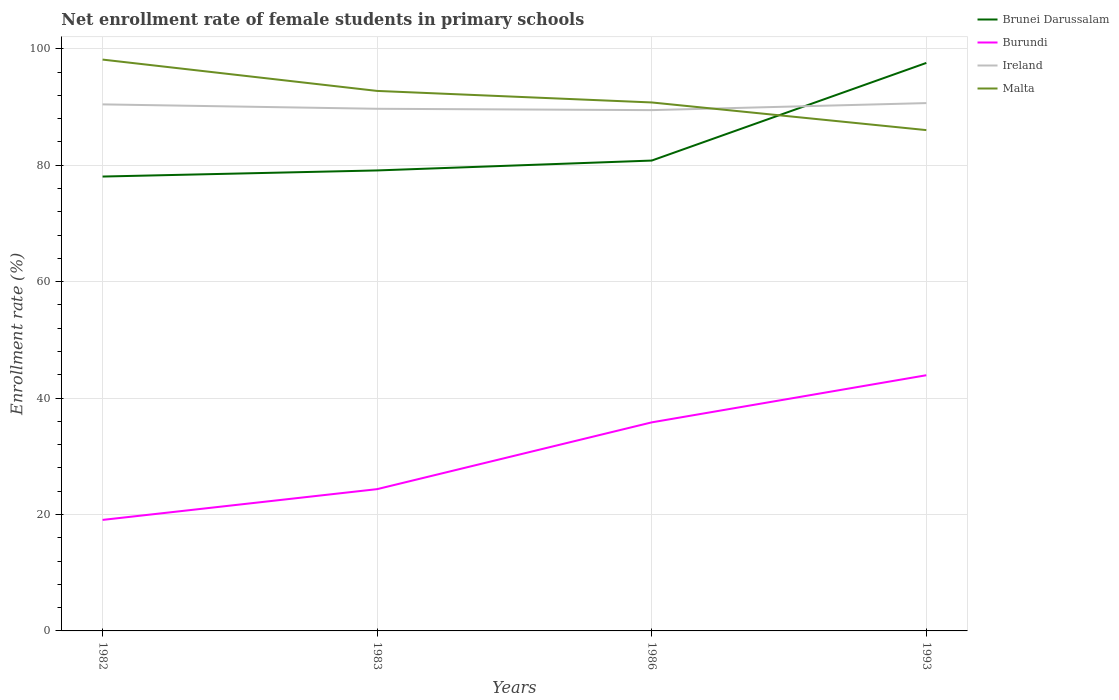How many different coloured lines are there?
Your response must be concise. 4. Does the line corresponding to Burundi intersect with the line corresponding to Brunei Darussalam?
Give a very brief answer. No. Across all years, what is the maximum net enrollment rate of female students in primary schools in Malta?
Ensure brevity in your answer.  86.04. In which year was the net enrollment rate of female students in primary schools in Malta maximum?
Give a very brief answer. 1993. What is the total net enrollment rate of female students in primary schools in Brunei Darussalam in the graph?
Give a very brief answer. -2.75. What is the difference between the highest and the second highest net enrollment rate of female students in primary schools in Burundi?
Your answer should be compact. 24.85. How many years are there in the graph?
Ensure brevity in your answer.  4. Does the graph contain any zero values?
Your response must be concise. No. How many legend labels are there?
Offer a terse response. 4. How are the legend labels stacked?
Offer a very short reply. Vertical. What is the title of the graph?
Your answer should be very brief. Net enrollment rate of female students in primary schools. Does "Russian Federation" appear as one of the legend labels in the graph?
Keep it short and to the point. No. What is the label or title of the Y-axis?
Your answer should be compact. Enrollment rate (%). What is the Enrollment rate (%) of Brunei Darussalam in 1982?
Give a very brief answer. 78.06. What is the Enrollment rate (%) in Burundi in 1982?
Your answer should be compact. 19.07. What is the Enrollment rate (%) in Ireland in 1982?
Provide a succinct answer. 90.46. What is the Enrollment rate (%) in Malta in 1982?
Your response must be concise. 98.16. What is the Enrollment rate (%) of Brunei Darussalam in 1983?
Offer a terse response. 79.11. What is the Enrollment rate (%) of Burundi in 1983?
Offer a very short reply. 24.36. What is the Enrollment rate (%) of Ireland in 1983?
Give a very brief answer. 89.7. What is the Enrollment rate (%) of Malta in 1983?
Offer a terse response. 92.77. What is the Enrollment rate (%) in Brunei Darussalam in 1986?
Ensure brevity in your answer.  80.81. What is the Enrollment rate (%) of Burundi in 1986?
Ensure brevity in your answer.  35.83. What is the Enrollment rate (%) of Ireland in 1986?
Keep it short and to the point. 89.47. What is the Enrollment rate (%) of Malta in 1986?
Offer a very short reply. 90.79. What is the Enrollment rate (%) in Brunei Darussalam in 1993?
Offer a very short reply. 97.58. What is the Enrollment rate (%) in Burundi in 1993?
Your response must be concise. 43.93. What is the Enrollment rate (%) of Ireland in 1993?
Offer a terse response. 90.68. What is the Enrollment rate (%) of Malta in 1993?
Provide a succinct answer. 86.04. Across all years, what is the maximum Enrollment rate (%) of Brunei Darussalam?
Keep it short and to the point. 97.58. Across all years, what is the maximum Enrollment rate (%) of Burundi?
Your answer should be compact. 43.93. Across all years, what is the maximum Enrollment rate (%) of Ireland?
Provide a short and direct response. 90.68. Across all years, what is the maximum Enrollment rate (%) in Malta?
Provide a succinct answer. 98.16. Across all years, what is the minimum Enrollment rate (%) of Brunei Darussalam?
Ensure brevity in your answer.  78.06. Across all years, what is the minimum Enrollment rate (%) of Burundi?
Keep it short and to the point. 19.07. Across all years, what is the minimum Enrollment rate (%) in Ireland?
Provide a short and direct response. 89.47. Across all years, what is the minimum Enrollment rate (%) of Malta?
Keep it short and to the point. 86.04. What is the total Enrollment rate (%) of Brunei Darussalam in the graph?
Ensure brevity in your answer.  335.56. What is the total Enrollment rate (%) in Burundi in the graph?
Offer a very short reply. 123.19. What is the total Enrollment rate (%) of Ireland in the graph?
Ensure brevity in your answer.  360.32. What is the total Enrollment rate (%) in Malta in the graph?
Keep it short and to the point. 367.76. What is the difference between the Enrollment rate (%) of Brunei Darussalam in 1982 and that in 1983?
Keep it short and to the point. -1.05. What is the difference between the Enrollment rate (%) in Burundi in 1982 and that in 1983?
Ensure brevity in your answer.  -5.29. What is the difference between the Enrollment rate (%) in Ireland in 1982 and that in 1983?
Your answer should be very brief. 0.76. What is the difference between the Enrollment rate (%) of Malta in 1982 and that in 1983?
Provide a short and direct response. 5.38. What is the difference between the Enrollment rate (%) in Brunei Darussalam in 1982 and that in 1986?
Your answer should be compact. -2.75. What is the difference between the Enrollment rate (%) of Burundi in 1982 and that in 1986?
Provide a short and direct response. -16.76. What is the difference between the Enrollment rate (%) of Ireland in 1982 and that in 1986?
Provide a short and direct response. 0.99. What is the difference between the Enrollment rate (%) of Malta in 1982 and that in 1986?
Ensure brevity in your answer.  7.36. What is the difference between the Enrollment rate (%) in Brunei Darussalam in 1982 and that in 1993?
Keep it short and to the point. -19.52. What is the difference between the Enrollment rate (%) in Burundi in 1982 and that in 1993?
Ensure brevity in your answer.  -24.85. What is the difference between the Enrollment rate (%) in Ireland in 1982 and that in 1993?
Offer a terse response. -0.22. What is the difference between the Enrollment rate (%) of Malta in 1982 and that in 1993?
Give a very brief answer. 12.11. What is the difference between the Enrollment rate (%) in Brunei Darussalam in 1983 and that in 1986?
Your answer should be very brief. -1.7. What is the difference between the Enrollment rate (%) of Burundi in 1983 and that in 1986?
Your answer should be very brief. -11.47. What is the difference between the Enrollment rate (%) of Ireland in 1983 and that in 1986?
Provide a succinct answer. 0.23. What is the difference between the Enrollment rate (%) in Malta in 1983 and that in 1986?
Your answer should be very brief. 1.98. What is the difference between the Enrollment rate (%) in Brunei Darussalam in 1983 and that in 1993?
Give a very brief answer. -18.47. What is the difference between the Enrollment rate (%) in Burundi in 1983 and that in 1993?
Provide a short and direct response. -19.57. What is the difference between the Enrollment rate (%) of Ireland in 1983 and that in 1993?
Give a very brief answer. -0.98. What is the difference between the Enrollment rate (%) of Malta in 1983 and that in 1993?
Offer a terse response. 6.73. What is the difference between the Enrollment rate (%) of Brunei Darussalam in 1986 and that in 1993?
Your answer should be very brief. -16.77. What is the difference between the Enrollment rate (%) of Burundi in 1986 and that in 1993?
Provide a succinct answer. -8.1. What is the difference between the Enrollment rate (%) in Ireland in 1986 and that in 1993?
Offer a terse response. -1.21. What is the difference between the Enrollment rate (%) in Malta in 1986 and that in 1993?
Keep it short and to the point. 4.75. What is the difference between the Enrollment rate (%) in Brunei Darussalam in 1982 and the Enrollment rate (%) in Burundi in 1983?
Ensure brevity in your answer.  53.7. What is the difference between the Enrollment rate (%) in Brunei Darussalam in 1982 and the Enrollment rate (%) in Ireland in 1983?
Your answer should be very brief. -11.64. What is the difference between the Enrollment rate (%) of Brunei Darussalam in 1982 and the Enrollment rate (%) of Malta in 1983?
Your answer should be compact. -14.71. What is the difference between the Enrollment rate (%) of Burundi in 1982 and the Enrollment rate (%) of Ireland in 1983?
Your answer should be compact. -70.63. What is the difference between the Enrollment rate (%) in Burundi in 1982 and the Enrollment rate (%) in Malta in 1983?
Ensure brevity in your answer.  -73.7. What is the difference between the Enrollment rate (%) in Ireland in 1982 and the Enrollment rate (%) in Malta in 1983?
Offer a terse response. -2.31. What is the difference between the Enrollment rate (%) in Brunei Darussalam in 1982 and the Enrollment rate (%) in Burundi in 1986?
Your answer should be compact. 42.23. What is the difference between the Enrollment rate (%) of Brunei Darussalam in 1982 and the Enrollment rate (%) of Ireland in 1986?
Give a very brief answer. -11.41. What is the difference between the Enrollment rate (%) of Brunei Darussalam in 1982 and the Enrollment rate (%) of Malta in 1986?
Your response must be concise. -12.73. What is the difference between the Enrollment rate (%) of Burundi in 1982 and the Enrollment rate (%) of Ireland in 1986?
Keep it short and to the point. -70.4. What is the difference between the Enrollment rate (%) of Burundi in 1982 and the Enrollment rate (%) of Malta in 1986?
Provide a succinct answer. -71.72. What is the difference between the Enrollment rate (%) in Ireland in 1982 and the Enrollment rate (%) in Malta in 1986?
Your response must be concise. -0.33. What is the difference between the Enrollment rate (%) of Brunei Darussalam in 1982 and the Enrollment rate (%) of Burundi in 1993?
Provide a short and direct response. 34.13. What is the difference between the Enrollment rate (%) of Brunei Darussalam in 1982 and the Enrollment rate (%) of Ireland in 1993?
Make the answer very short. -12.62. What is the difference between the Enrollment rate (%) in Brunei Darussalam in 1982 and the Enrollment rate (%) in Malta in 1993?
Your answer should be compact. -7.98. What is the difference between the Enrollment rate (%) of Burundi in 1982 and the Enrollment rate (%) of Ireland in 1993?
Provide a short and direct response. -71.61. What is the difference between the Enrollment rate (%) in Burundi in 1982 and the Enrollment rate (%) in Malta in 1993?
Offer a terse response. -66.97. What is the difference between the Enrollment rate (%) in Ireland in 1982 and the Enrollment rate (%) in Malta in 1993?
Ensure brevity in your answer.  4.42. What is the difference between the Enrollment rate (%) in Brunei Darussalam in 1983 and the Enrollment rate (%) in Burundi in 1986?
Your answer should be compact. 43.28. What is the difference between the Enrollment rate (%) of Brunei Darussalam in 1983 and the Enrollment rate (%) of Ireland in 1986?
Offer a terse response. -10.36. What is the difference between the Enrollment rate (%) of Brunei Darussalam in 1983 and the Enrollment rate (%) of Malta in 1986?
Offer a terse response. -11.68. What is the difference between the Enrollment rate (%) of Burundi in 1983 and the Enrollment rate (%) of Ireland in 1986?
Offer a very short reply. -65.11. What is the difference between the Enrollment rate (%) in Burundi in 1983 and the Enrollment rate (%) in Malta in 1986?
Offer a very short reply. -66.43. What is the difference between the Enrollment rate (%) of Ireland in 1983 and the Enrollment rate (%) of Malta in 1986?
Your answer should be compact. -1.09. What is the difference between the Enrollment rate (%) in Brunei Darussalam in 1983 and the Enrollment rate (%) in Burundi in 1993?
Offer a very short reply. 35.19. What is the difference between the Enrollment rate (%) of Brunei Darussalam in 1983 and the Enrollment rate (%) of Ireland in 1993?
Offer a very short reply. -11.57. What is the difference between the Enrollment rate (%) of Brunei Darussalam in 1983 and the Enrollment rate (%) of Malta in 1993?
Make the answer very short. -6.93. What is the difference between the Enrollment rate (%) of Burundi in 1983 and the Enrollment rate (%) of Ireland in 1993?
Offer a very short reply. -66.32. What is the difference between the Enrollment rate (%) of Burundi in 1983 and the Enrollment rate (%) of Malta in 1993?
Provide a succinct answer. -61.68. What is the difference between the Enrollment rate (%) of Ireland in 1983 and the Enrollment rate (%) of Malta in 1993?
Offer a terse response. 3.66. What is the difference between the Enrollment rate (%) of Brunei Darussalam in 1986 and the Enrollment rate (%) of Burundi in 1993?
Your answer should be very brief. 36.88. What is the difference between the Enrollment rate (%) in Brunei Darussalam in 1986 and the Enrollment rate (%) in Ireland in 1993?
Make the answer very short. -9.87. What is the difference between the Enrollment rate (%) of Brunei Darussalam in 1986 and the Enrollment rate (%) of Malta in 1993?
Ensure brevity in your answer.  -5.23. What is the difference between the Enrollment rate (%) of Burundi in 1986 and the Enrollment rate (%) of Ireland in 1993?
Your answer should be compact. -54.85. What is the difference between the Enrollment rate (%) in Burundi in 1986 and the Enrollment rate (%) in Malta in 1993?
Offer a very short reply. -50.21. What is the difference between the Enrollment rate (%) in Ireland in 1986 and the Enrollment rate (%) in Malta in 1993?
Offer a very short reply. 3.43. What is the average Enrollment rate (%) of Brunei Darussalam per year?
Provide a succinct answer. 83.89. What is the average Enrollment rate (%) in Burundi per year?
Offer a terse response. 30.8. What is the average Enrollment rate (%) of Ireland per year?
Offer a very short reply. 90.08. What is the average Enrollment rate (%) of Malta per year?
Make the answer very short. 91.94. In the year 1982, what is the difference between the Enrollment rate (%) in Brunei Darussalam and Enrollment rate (%) in Burundi?
Ensure brevity in your answer.  58.99. In the year 1982, what is the difference between the Enrollment rate (%) of Brunei Darussalam and Enrollment rate (%) of Ireland?
Give a very brief answer. -12.4. In the year 1982, what is the difference between the Enrollment rate (%) of Brunei Darussalam and Enrollment rate (%) of Malta?
Offer a very short reply. -20.09. In the year 1982, what is the difference between the Enrollment rate (%) of Burundi and Enrollment rate (%) of Ireland?
Offer a terse response. -71.39. In the year 1982, what is the difference between the Enrollment rate (%) of Burundi and Enrollment rate (%) of Malta?
Your answer should be compact. -79.08. In the year 1982, what is the difference between the Enrollment rate (%) in Ireland and Enrollment rate (%) in Malta?
Give a very brief answer. -7.69. In the year 1983, what is the difference between the Enrollment rate (%) in Brunei Darussalam and Enrollment rate (%) in Burundi?
Keep it short and to the point. 54.75. In the year 1983, what is the difference between the Enrollment rate (%) of Brunei Darussalam and Enrollment rate (%) of Ireland?
Make the answer very short. -10.59. In the year 1983, what is the difference between the Enrollment rate (%) of Brunei Darussalam and Enrollment rate (%) of Malta?
Your answer should be very brief. -13.66. In the year 1983, what is the difference between the Enrollment rate (%) in Burundi and Enrollment rate (%) in Ireland?
Your response must be concise. -65.34. In the year 1983, what is the difference between the Enrollment rate (%) of Burundi and Enrollment rate (%) of Malta?
Ensure brevity in your answer.  -68.41. In the year 1983, what is the difference between the Enrollment rate (%) in Ireland and Enrollment rate (%) in Malta?
Ensure brevity in your answer.  -3.07. In the year 1986, what is the difference between the Enrollment rate (%) in Brunei Darussalam and Enrollment rate (%) in Burundi?
Ensure brevity in your answer.  44.98. In the year 1986, what is the difference between the Enrollment rate (%) of Brunei Darussalam and Enrollment rate (%) of Ireland?
Keep it short and to the point. -8.66. In the year 1986, what is the difference between the Enrollment rate (%) of Brunei Darussalam and Enrollment rate (%) of Malta?
Provide a short and direct response. -9.98. In the year 1986, what is the difference between the Enrollment rate (%) in Burundi and Enrollment rate (%) in Ireland?
Keep it short and to the point. -53.64. In the year 1986, what is the difference between the Enrollment rate (%) of Burundi and Enrollment rate (%) of Malta?
Your answer should be very brief. -54.96. In the year 1986, what is the difference between the Enrollment rate (%) of Ireland and Enrollment rate (%) of Malta?
Give a very brief answer. -1.32. In the year 1993, what is the difference between the Enrollment rate (%) of Brunei Darussalam and Enrollment rate (%) of Burundi?
Offer a terse response. 53.66. In the year 1993, what is the difference between the Enrollment rate (%) of Brunei Darussalam and Enrollment rate (%) of Ireland?
Provide a succinct answer. 6.9. In the year 1993, what is the difference between the Enrollment rate (%) of Brunei Darussalam and Enrollment rate (%) of Malta?
Your answer should be very brief. 11.54. In the year 1993, what is the difference between the Enrollment rate (%) of Burundi and Enrollment rate (%) of Ireland?
Ensure brevity in your answer.  -46.75. In the year 1993, what is the difference between the Enrollment rate (%) in Burundi and Enrollment rate (%) in Malta?
Your response must be concise. -42.11. In the year 1993, what is the difference between the Enrollment rate (%) in Ireland and Enrollment rate (%) in Malta?
Keep it short and to the point. 4.64. What is the ratio of the Enrollment rate (%) of Brunei Darussalam in 1982 to that in 1983?
Offer a very short reply. 0.99. What is the ratio of the Enrollment rate (%) in Burundi in 1982 to that in 1983?
Offer a terse response. 0.78. What is the ratio of the Enrollment rate (%) of Ireland in 1982 to that in 1983?
Your response must be concise. 1.01. What is the ratio of the Enrollment rate (%) of Malta in 1982 to that in 1983?
Provide a short and direct response. 1.06. What is the ratio of the Enrollment rate (%) of Brunei Darussalam in 1982 to that in 1986?
Your response must be concise. 0.97. What is the ratio of the Enrollment rate (%) of Burundi in 1982 to that in 1986?
Keep it short and to the point. 0.53. What is the ratio of the Enrollment rate (%) in Ireland in 1982 to that in 1986?
Provide a short and direct response. 1.01. What is the ratio of the Enrollment rate (%) of Malta in 1982 to that in 1986?
Your answer should be compact. 1.08. What is the ratio of the Enrollment rate (%) in Burundi in 1982 to that in 1993?
Make the answer very short. 0.43. What is the ratio of the Enrollment rate (%) of Ireland in 1982 to that in 1993?
Your answer should be very brief. 1. What is the ratio of the Enrollment rate (%) of Malta in 1982 to that in 1993?
Your response must be concise. 1.14. What is the ratio of the Enrollment rate (%) in Burundi in 1983 to that in 1986?
Your answer should be very brief. 0.68. What is the ratio of the Enrollment rate (%) of Ireland in 1983 to that in 1986?
Your answer should be very brief. 1. What is the ratio of the Enrollment rate (%) in Malta in 1983 to that in 1986?
Your answer should be compact. 1.02. What is the ratio of the Enrollment rate (%) of Brunei Darussalam in 1983 to that in 1993?
Ensure brevity in your answer.  0.81. What is the ratio of the Enrollment rate (%) in Burundi in 1983 to that in 1993?
Ensure brevity in your answer.  0.55. What is the ratio of the Enrollment rate (%) in Malta in 1983 to that in 1993?
Make the answer very short. 1.08. What is the ratio of the Enrollment rate (%) in Brunei Darussalam in 1986 to that in 1993?
Keep it short and to the point. 0.83. What is the ratio of the Enrollment rate (%) of Burundi in 1986 to that in 1993?
Your answer should be compact. 0.82. What is the ratio of the Enrollment rate (%) of Ireland in 1986 to that in 1993?
Your answer should be compact. 0.99. What is the ratio of the Enrollment rate (%) in Malta in 1986 to that in 1993?
Offer a very short reply. 1.06. What is the difference between the highest and the second highest Enrollment rate (%) of Brunei Darussalam?
Offer a terse response. 16.77. What is the difference between the highest and the second highest Enrollment rate (%) in Burundi?
Give a very brief answer. 8.1. What is the difference between the highest and the second highest Enrollment rate (%) in Ireland?
Give a very brief answer. 0.22. What is the difference between the highest and the second highest Enrollment rate (%) in Malta?
Ensure brevity in your answer.  5.38. What is the difference between the highest and the lowest Enrollment rate (%) in Brunei Darussalam?
Your answer should be compact. 19.52. What is the difference between the highest and the lowest Enrollment rate (%) in Burundi?
Offer a terse response. 24.85. What is the difference between the highest and the lowest Enrollment rate (%) in Ireland?
Your answer should be compact. 1.21. What is the difference between the highest and the lowest Enrollment rate (%) of Malta?
Ensure brevity in your answer.  12.11. 